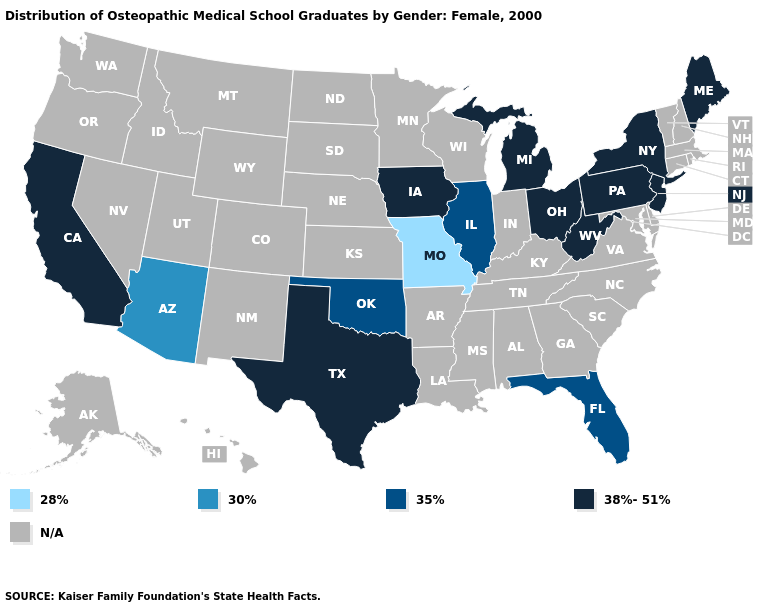What is the lowest value in the Northeast?
Give a very brief answer. 38%-51%. Which states have the highest value in the USA?
Be succinct. California, Iowa, Maine, Michigan, New Jersey, New York, Ohio, Pennsylvania, Texas, West Virginia. What is the value of Virginia?
Be succinct. N/A. Among the states that border Kentucky , does Missouri have the lowest value?
Short answer required. Yes. Is the legend a continuous bar?
Be succinct. No. What is the value of Hawaii?
Be succinct. N/A. Which states have the highest value in the USA?
Write a very short answer. California, Iowa, Maine, Michigan, New Jersey, New York, Ohio, Pennsylvania, Texas, West Virginia. Does Oklahoma have the highest value in the South?
Concise answer only. No. Name the states that have a value in the range 28%?
Give a very brief answer. Missouri. Does West Virginia have the highest value in the USA?
Give a very brief answer. Yes. Does the first symbol in the legend represent the smallest category?
Keep it brief. Yes. What is the value of Vermont?
Short answer required. N/A. What is the lowest value in states that border Nevada?
Be succinct. 30%. Does Missouri have the lowest value in the USA?
Be succinct. Yes. Which states hav the highest value in the West?
Give a very brief answer. California. 